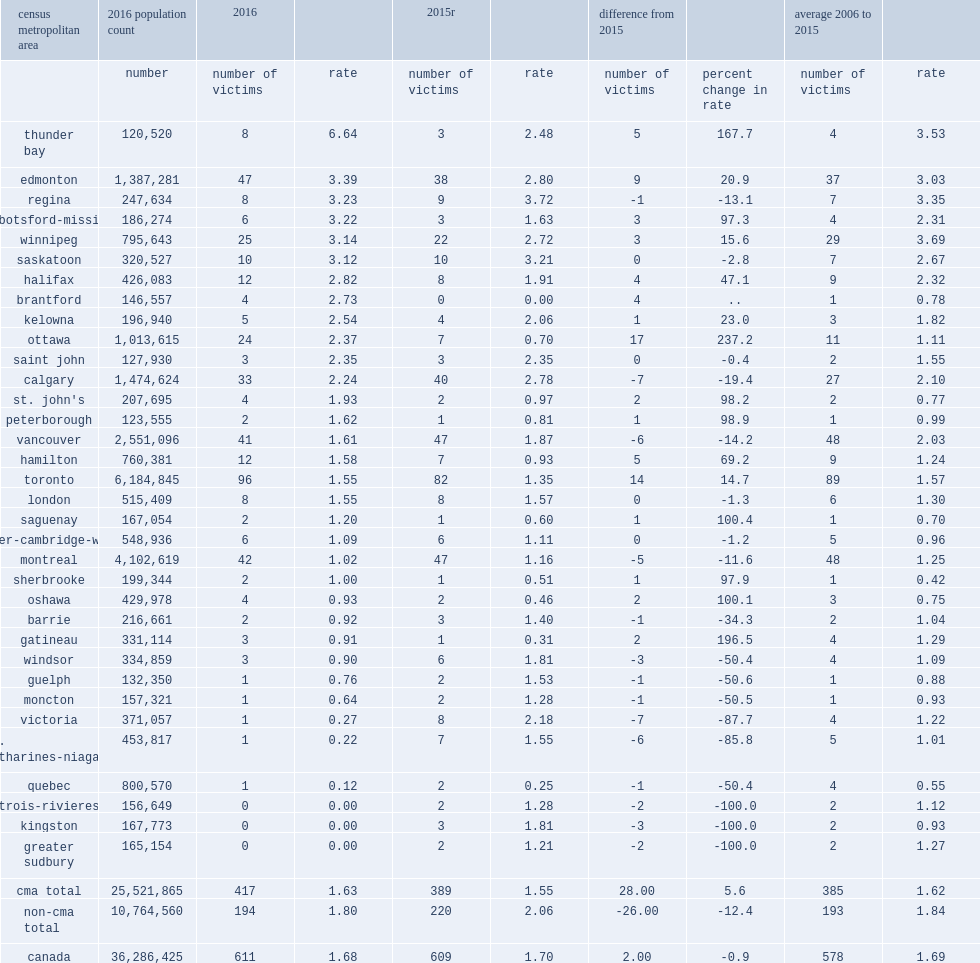Which cma reported the largest decrease in the homicide rates from the previous year? Victoria. Which cma recorded the highest homicide rate in 2016? Thunder bay. Except thunder bay,list the top2 cmas which had the highest homicide rates in 2016. Edmonton regina. Which cma reported the highest number of homicides in 2016? Toronto. What was the rate of homicides in ottawa in 2016? 2.37. Which cma reported the highest homicide rate in the province in 2016? Thunder bay. 